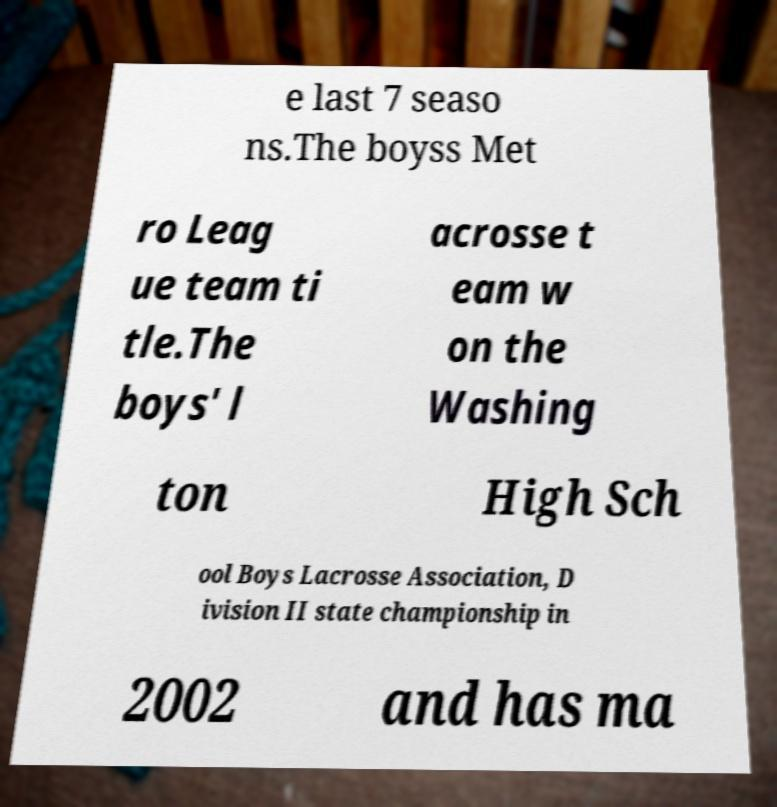For documentation purposes, I need the text within this image transcribed. Could you provide that? e last 7 seaso ns.The boyss Met ro Leag ue team ti tle.The boys' l acrosse t eam w on the Washing ton High Sch ool Boys Lacrosse Association, D ivision II state championship in 2002 and has ma 